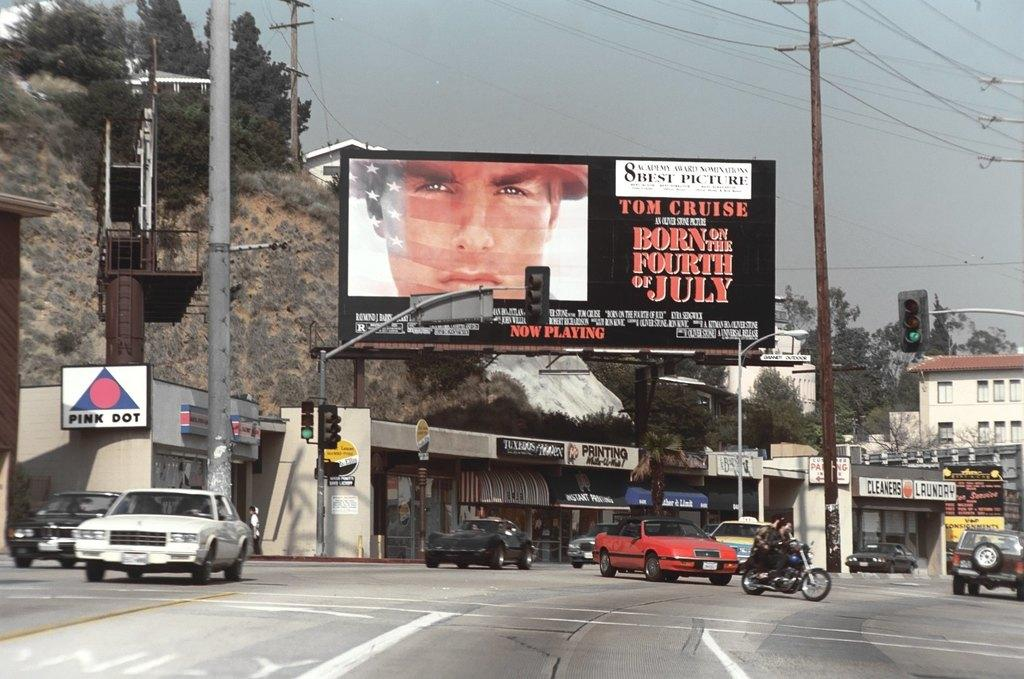<image>
Present a compact description of the photo's key features. A billboard for the film Born on the Fourth of July. 